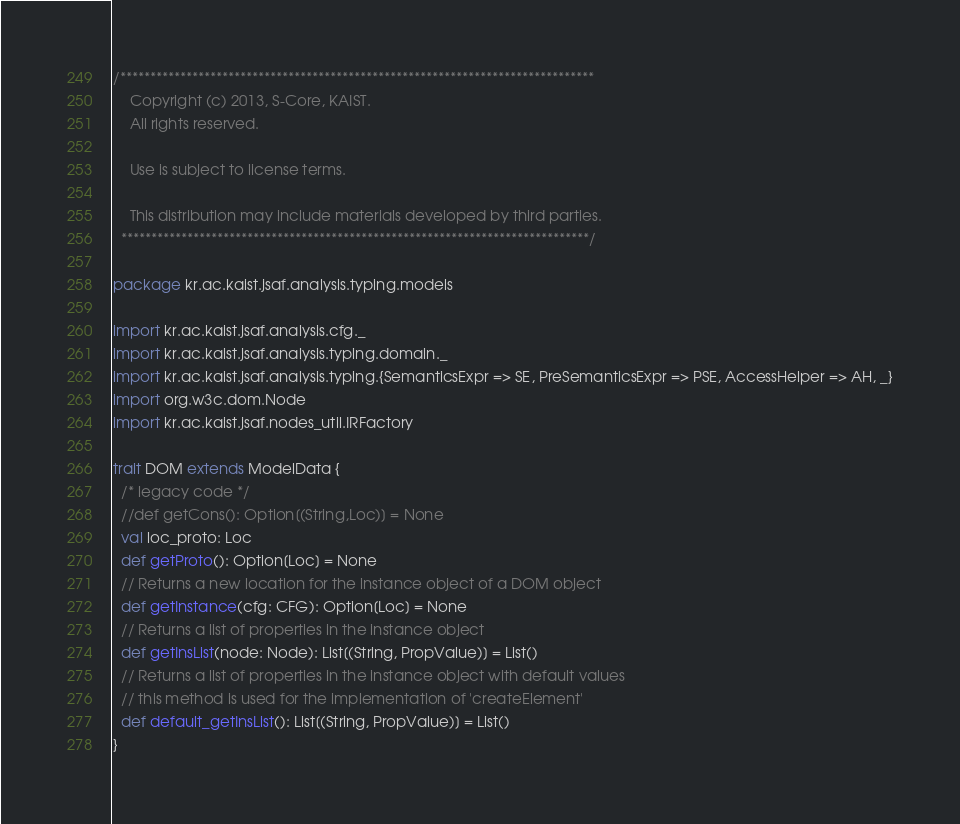Convert code to text. <code><loc_0><loc_0><loc_500><loc_500><_Scala_>/*******************************************************************************
    Copyright (c) 2013, S-Core, KAIST.
    All rights reserved.

    Use is subject to license terms.

    This distribution may include materials developed by third parties.
  ******************************************************************************/

package kr.ac.kaist.jsaf.analysis.typing.models

import kr.ac.kaist.jsaf.analysis.cfg._
import kr.ac.kaist.jsaf.analysis.typing.domain._
import kr.ac.kaist.jsaf.analysis.typing.{SemanticsExpr => SE, PreSemanticsExpr => PSE, AccessHelper => AH, _}
import org.w3c.dom.Node
import kr.ac.kaist.jsaf.nodes_util.IRFactory

trait DOM extends ModelData {
  /* legacy code */
  //def getCons(): Option[(String,Loc)] = None
  val loc_proto: Loc 
  def getProto(): Option[Loc] = None
  // Returns a new location for the instance object of a DOM object 
  def getInstance(cfg: CFG): Option[Loc] = None
  // Returns a list of properties in the instance object
  def getInsList(node: Node): List[(String, PropValue)] = List()
  // Returns a list of properties in the instance object with default values
  // this method is used for the implementation of 'createElement'
  def default_getInsList(): List[(String, PropValue)] = List()
}

</code> 